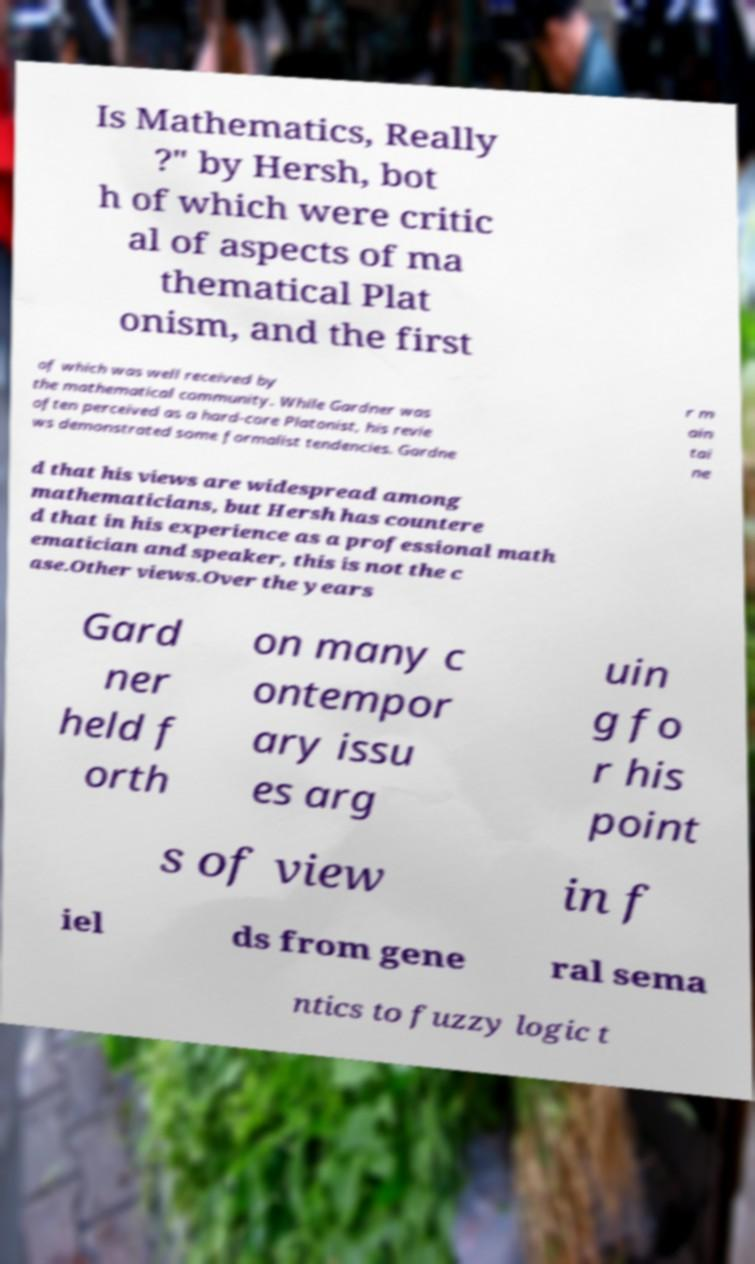Can you read and provide the text displayed in the image?This photo seems to have some interesting text. Can you extract and type it out for me? Is Mathematics, Really ?" by Hersh, bot h of which were critic al of aspects of ma thematical Plat onism, and the first of which was well received by the mathematical community. While Gardner was often perceived as a hard-core Platonist, his revie ws demonstrated some formalist tendencies. Gardne r m ain tai ne d that his views are widespread among mathematicians, but Hersh has countere d that in his experience as a professional math ematician and speaker, this is not the c ase.Other views.Over the years Gard ner held f orth on many c ontempor ary issu es arg uin g fo r his point s of view in f iel ds from gene ral sema ntics to fuzzy logic t 